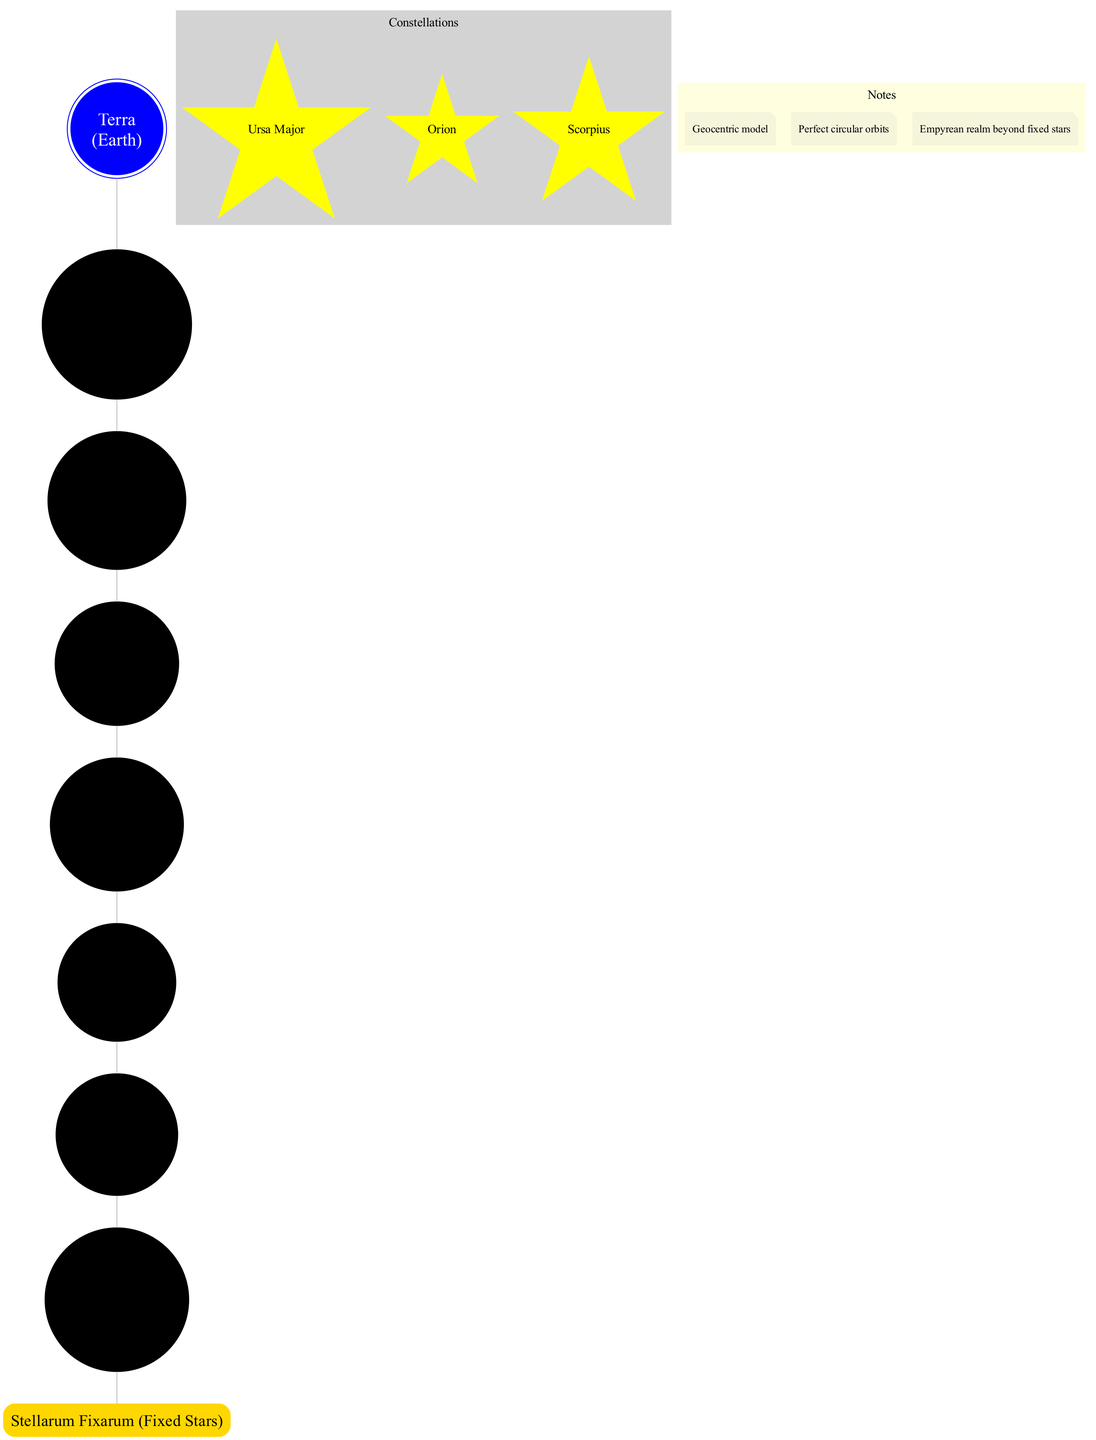What is the center of the diagram? The diagram indicates that the center of the universe, according to ancient Roman astronomers, is "Terra (Earth)." This is represented by the central node in the diagram.
Answer: Terra (Earth) What is the distance of Luna from Earth? Luna is noted as being the "Closest to Earth" in the diagram, which is the first celestial sphere surrounding the Earth.
Answer: Closest to Earth How many celestial spheres are depicted in the diagram? The diagram includes a total of seven celestial spheres surrounding the Earth, which can be counted from the nodes representing each planet and the Moon.
Answer: 7 Which celestial body is furthest from Earth? The furthest celestial body in the diagram is represented by the outer sphere labeled "Stellarum Fixarum (Fixed Stars)," which encapsulates all other celestial spheres.
Answer: Stellarum Fixarum (Fixed Stars) What is one of the constellations shown in the diagram? The diagram illustrates a few constellations among its features; one example is "Ursa Major." This can be identified within the cluster designated for constellations.
Answer: Ursa Major What type of model is represented in the diagram? The diagram explicitly notes that it follows a "Geocentric model," which establishes Earth as the center of the universe, surrounded by celestial bodies.
Answer: Geocentric model What do the notes indicate about the orbits of the celestial bodies? One of the notes states, "Perfect circular orbits," indicating that the diagram's representation of celestial bodies assumes they move in perfect circular paths around the Earth.
Answer: Perfect circular orbits Which celestial body is the fourth sphere according to the diagram? The fourth sphere in the diagram is labeled "Sol (Sun)," indicating its sequential placement in relation to Earth and other celestial bodies.
Answer: Sol (Sun) How many constellations are featured in the diagram? The diagram features three specific constellations, which are listed explicitly in the constellation section of the diagram.
Answer: 3 What realm is depicted beyond the fixed stars? The diagram mentions an "Empyrean realm" that exists beyond the fixed stars, indicating a further layer in their cosmic understanding.
Answer: Empyrean realm 